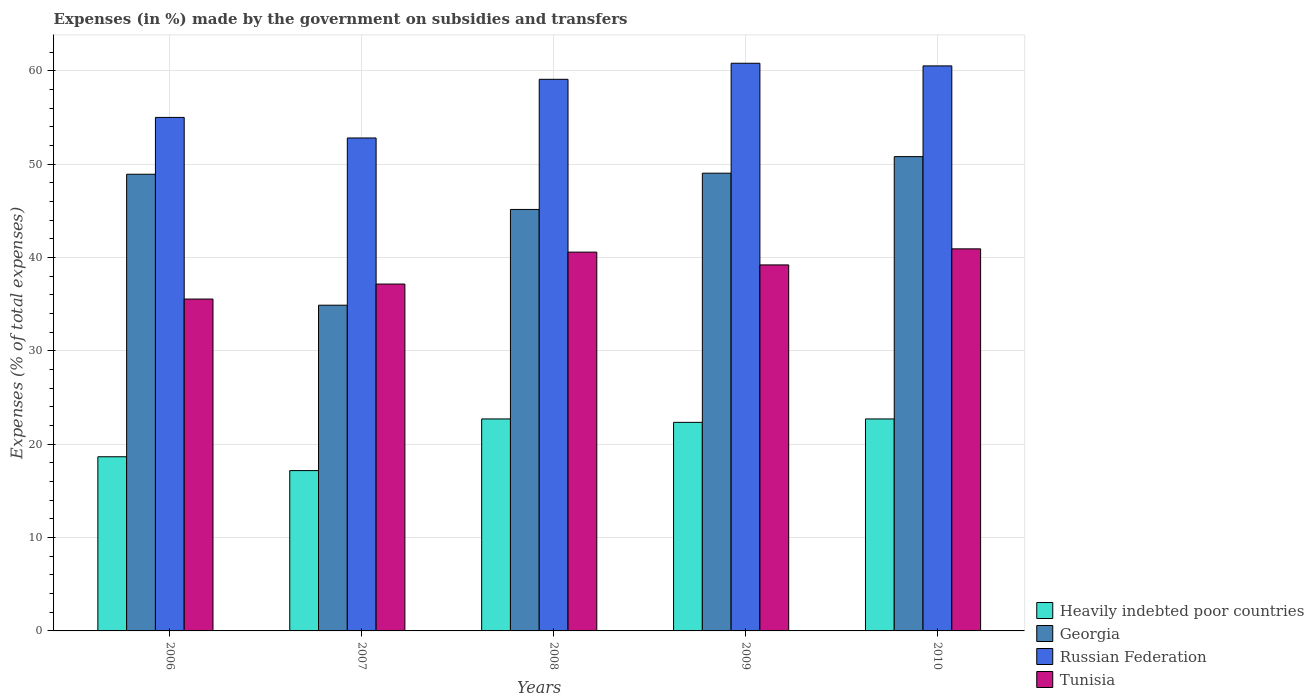How many different coloured bars are there?
Provide a short and direct response. 4. How many groups of bars are there?
Offer a very short reply. 5. Are the number of bars per tick equal to the number of legend labels?
Offer a terse response. Yes. How many bars are there on the 4th tick from the left?
Give a very brief answer. 4. In how many cases, is the number of bars for a given year not equal to the number of legend labels?
Keep it short and to the point. 0. What is the percentage of expenses made by the government on subsidies and transfers in Russian Federation in 2010?
Your answer should be very brief. 60.52. Across all years, what is the maximum percentage of expenses made by the government on subsidies and transfers in Tunisia?
Ensure brevity in your answer.  40.92. Across all years, what is the minimum percentage of expenses made by the government on subsidies and transfers in Georgia?
Offer a terse response. 34.89. In which year was the percentage of expenses made by the government on subsidies and transfers in Heavily indebted poor countries maximum?
Keep it short and to the point. 2010. What is the total percentage of expenses made by the government on subsidies and transfers in Georgia in the graph?
Give a very brief answer. 228.77. What is the difference between the percentage of expenses made by the government on subsidies and transfers in Russian Federation in 2009 and that in 2010?
Your answer should be very brief. 0.28. What is the difference between the percentage of expenses made by the government on subsidies and transfers in Russian Federation in 2007 and the percentage of expenses made by the government on subsidies and transfers in Heavily indebted poor countries in 2006?
Offer a terse response. 34.14. What is the average percentage of expenses made by the government on subsidies and transfers in Heavily indebted poor countries per year?
Provide a short and direct response. 20.71. In the year 2008, what is the difference between the percentage of expenses made by the government on subsidies and transfers in Russian Federation and percentage of expenses made by the government on subsidies and transfers in Georgia?
Your answer should be very brief. 13.94. In how many years, is the percentage of expenses made by the government on subsidies and transfers in Heavily indebted poor countries greater than 18 %?
Your answer should be compact. 4. What is the ratio of the percentage of expenses made by the government on subsidies and transfers in Heavily indebted poor countries in 2008 to that in 2010?
Keep it short and to the point. 1. What is the difference between the highest and the second highest percentage of expenses made by the government on subsidies and transfers in Tunisia?
Ensure brevity in your answer.  0.35. What is the difference between the highest and the lowest percentage of expenses made by the government on subsidies and transfers in Georgia?
Offer a very short reply. 15.91. In how many years, is the percentage of expenses made by the government on subsidies and transfers in Russian Federation greater than the average percentage of expenses made by the government on subsidies and transfers in Russian Federation taken over all years?
Offer a very short reply. 3. Is the sum of the percentage of expenses made by the government on subsidies and transfers in Russian Federation in 2008 and 2009 greater than the maximum percentage of expenses made by the government on subsidies and transfers in Georgia across all years?
Provide a succinct answer. Yes. Is it the case that in every year, the sum of the percentage of expenses made by the government on subsidies and transfers in Tunisia and percentage of expenses made by the government on subsidies and transfers in Heavily indebted poor countries is greater than the sum of percentage of expenses made by the government on subsidies and transfers in Russian Federation and percentage of expenses made by the government on subsidies and transfers in Georgia?
Keep it short and to the point. No. What does the 4th bar from the left in 2009 represents?
Your answer should be very brief. Tunisia. What does the 3rd bar from the right in 2007 represents?
Keep it short and to the point. Georgia. Are all the bars in the graph horizontal?
Offer a very short reply. No. What is the difference between two consecutive major ticks on the Y-axis?
Make the answer very short. 10. Does the graph contain any zero values?
Provide a succinct answer. No. How many legend labels are there?
Your answer should be very brief. 4. What is the title of the graph?
Give a very brief answer. Expenses (in %) made by the government on subsidies and transfers. Does "St. Vincent and the Grenadines" appear as one of the legend labels in the graph?
Ensure brevity in your answer.  No. What is the label or title of the X-axis?
Offer a terse response. Years. What is the label or title of the Y-axis?
Give a very brief answer. Expenses (% of total expenses). What is the Expenses (% of total expenses) of Heavily indebted poor countries in 2006?
Keep it short and to the point. 18.65. What is the Expenses (% of total expenses) of Georgia in 2006?
Offer a very short reply. 48.91. What is the Expenses (% of total expenses) of Russian Federation in 2006?
Ensure brevity in your answer.  55. What is the Expenses (% of total expenses) of Tunisia in 2006?
Keep it short and to the point. 35.55. What is the Expenses (% of total expenses) in Heavily indebted poor countries in 2007?
Make the answer very short. 17.17. What is the Expenses (% of total expenses) of Georgia in 2007?
Make the answer very short. 34.89. What is the Expenses (% of total expenses) of Russian Federation in 2007?
Keep it short and to the point. 52.8. What is the Expenses (% of total expenses) of Tunisia in 2007?
Your answer should be very brief. 37.15. What is the Expenses (% of total expenses) in Heavily indebted poor countries in 2008?
Offer a very short reply. 22.7. What is the Expenses (% of total expenses) in Georgia in 2008?
Your answer should be compact. 45.14. What is the Expenses (% of total expenses) of Russian Federation in 2008?
Provide a succinct answer. 59.08. What is the Expenses (% of total expenses) in Tunisia in 2008?
Ensure brevity in your answer.  40.57. What is the Expenses (% of total expenses) in Heavily indebted poor countries in 2009?
Provide a short and direct response. 22.34. What is the Expenses (% of total expenses) in Georgia in 2009?
Your answer should be very brief. 49.03. What is the Expenses (% of total expenses) of Russian Federation in 2009?
Keep it short and to the point. 60.8. What is the Expenses (% of total expenses) of Tunisia in 2009?
Provide a short and direct response. 39.2. What is the Expenses (% of total expenses) of Heavily indebted poor countries in 2010?
Ensure brevity in your answer.  22.7. What is the Expenses (% of total expenses) of Georgia in 2010?
Your answer should be compact. 50.8. What is the Expenses (% of total expenses) of Russian Federation in 2010?
Make the answer very short. 60.52. What is the Expenses (% of total expenses) in Tunisia in 2010?
Your answer should be compact. 40.92. Across all years, what is the maximum Expenses (% of total expenses) in Heavily indebted poor countries?
Your answer should be very brief. 22.7. Across all years, what is the maximum Expenses (% of total expenses) in Georgia?
Give a very brief answer. 50.8. Across all years, what is the maximum Expenses (% of total expenses) of Russian Federation?
Give a very brief answer. 60.8. Across all years, what is the maximum Expenses (% of total expenses) of Tunisia?
Make the answer very short. 40.92. Across all years, what is the minimum Expenses (% of total expenses) in Heavily indebted poor countries?
Your answer should be very brief. 17.17. Across all years, what is the minimum Expenses (% of total expenses) of Georgia?
Ensure brevity in your answer.  34.89. Across all years, what is the minimum Expenses (% of total expenses) of Russian Federation?
Provide a short and direct response. 52.8. Across all years, what is the minimum Expenses (% of total expenses) in Tunisia?
Offer a very short reply. 35.55. What is the total Expenses (% of total expenses) of Heavily indebted poor countries in the graph?
Offer a very short reply. 103.57. What is the total Expenses (% of total expenses) of Georgia in the graph?
Your answer should be very brief. 228.77. What is the total Expenses (% of total expenses) of Russian Federation in the graph?
Your response must be concise. 288.19. What is the total Expenses (% of total expenses) of Tunisia in the graph?
Your answer should be compact. 193.39. What is the difference between the Expenses (% of total expenses) in Heavily indebted poor countries in 2006 and that in 2007?
Provide a short and direct response. 1.48. What is the difference between the Expenses (% of total expenses) of Georgia in 2006 and that in 2007?
Keep it short and to the point. 14.03. What is the difference between the Expenses (% of total expenses) in Russian Federation in 2006 and that in 2007?
Your answer should be very brief. 2.2. What is the difference between the Expenses (% of total expenses) of Tunisia in 2006 and that in 2007?
Offer a terse response. -1.61. What is the difference between the Expenses (% of total expenses) of Heavily indebted poor countries in 2006 and that in 2008?
Offer a very short reply. -4.05. What is the difference between the Expenses (% of total expenses) of Georgia in 2006 and that in 2008?
Provide a short and direct response. 3.77. What is the difference between the Expenses (% of total expenses) of Russian Federation in 2006 and that in 2008?
Offer a terse response. -4.08. What is the difference between the Expenses (% of total expenses) in Tunisia in 2006 and that in 2008?
Keep it short and to the point. -5.03. What is the difference between the Expenses (% of total expenses) of Heavily indebted poor countries in 2006 and that in 2009?
Offer a very short reply. -3.69. What is the difference between the Expenses (% of total expenses) of Georgia in 2006 and that in 2009?
Ensure brevity in your answer.  -0.11. What is the difference between the Expenses (% of total expenses) in Russian Federation in 2006 and that in 2009?
Provide a succinct answer. -5.8. What is the difference between the Expenses (% of total expenses) in Tunisia in 2006 and that in 2009?
Your answer should be very brief. -3.66. What is the difference between the Expenses (% of total expenses) in Heavily indebted poor countries in 2006 and that in 2010?
Your answer should be compact. -4.05. What is the difference between the Expenses (% of total expenses) of Georgia in 2006 and that in 2010?
Provide a short and direct response. -1.89. What is the difference between the Expenses (% of total expenses) of Russian Federation in 2006 and that in 2010?
Your answer should be compact. -5.52. What is the difference between the Expenses (% of total expenses) of Tunisia in 2006 and that in 2010?
Give a very brief answer. -5.38. What is the difference between the Expenses (% of total expenses) in Heavily indebted poor countries in 2007 and that in 2008?
Give a very brief answer. -5.53. What is the difference between the Expenses (% of total expenses) of Georgia in 2007 and that in 2008?
Your response must be concise. -10.26. What is the difference between the Expenses (% of total expenses) in Russian Federation in 2007 and that in 2008?
Provide a succinct answer. -6.28. What is the difference between the Expenses (% of total expenses) of Tunisia in 2007 and that in 2008?
Your response must be concise. -3.42. What is the difference between the Expenses (% of total expenses) of Heavily indebted poor countries in 2007 and that in 2009?
Your answer should be compact. -5.17. What is the difference between the Expenses (% of total expenses) of Georgia in 2007 and that in 2009?
Provide a succinct answer. -14.14. What is the difference between the Expenses (% of total expenses) of Russian Federation in 2007 and that in 2009?
Offer a terse response. -8. What is the difference between the Expenses (% of total expenses) in Tunisia in 2007 and that in 2009?
Your answer should be very brief. -2.05. What is the difference between the Expenses (% of total expenses) in Heavily indebted poor countries in 2007 and that in 2010?
Provide a succinct answer. -5.53. What is the difference between the Expenses (% of total expenses) of Georgia in 2007 and that in 2010?
Provide a short and direct response. -15.91. What is the difference between the Expenses (% of total expenses) in Russian Federation in 2007 and that in 2010?
Keep it short and to the point. -7.72. What is the difference between the Expenses (% of total expenses) of Tunisia in 2007 and that in 2010?
Your response must be concise. -3.77. What is the difference between the Expenses (% of total expenses) in Heavily indebted poor countries in 2008 and that in 2009?
Your answer should be compact. 0.36. What is the difference between the Expenses (% of total expenses) in Georgia in 2008 and that in 2009?
Offer a very short reply. -3.88. What is the difference between the Expenses (% of total expenses) of Russian Federation in 2008 and that in 2009?
Provide a short and direct response. -1.72. What is the difference between the Expenses (% of total expenses) in Tunisia in 2008 and that in 2009?
Your response must be concise. 1.37. What is the difference between the Expenses (% of total expenses) of Heavily indebted poor countries in 2008 and that in 2010?
Offer a very short reply. -0. What is the difference between the Expenses (% of total expenses) in Georgia in 2008 and that in 2010?
Make the answer very short. -5.66. What is the difference between the Expenses (% of total expenses) of Russian Federation in 2008 and that in 2010?
Offer a terse response. -1.44. What is the difference between the Expenses (% of total expenses) in Tunisia in 2008 and that in 2010?
Your response must be concise. -0.35. What is the difference between the Expenses (% of total expenses) of Heavily indebted poor countries in 2009 and that in 2010?
Provide a short and direct response. -0.37. What is the difference between the Expenses (% of total expenses) in Georgia in 2009 and that in 2010?
Your answer should be very brief. -1.78. What is the difference between the Expenses (% of total expenses) in Russian Federation in 2009 and that in 2010?
Make the answer very short. 0.28. What is the difference between the Expenses (% of total expenses) of Tunisia in 2009 and that in 2010?
Offer a terse response. -1.72. What is the difference between the Expenses (% of total expenses) in Heavily indebted poor countries in 2006 and the Expenses (% of total expenses) in Georgia in 2007?
Your answer should be very brief. -16.23. What is the difference between the Expenses (% of total expenses) in Heavily indebted poor countries in 2006 and the Expenses (% of total expenses) in Russian Federation in 2007?
Make the answer very short. -34.14. What is the difference between the Expenses (% of total expenses) of Heavily indebted poor countries in 2006 and the Expenses (% of total expenses) of Tunisia in 2007?
Your answer should be very brief. -18.5. What is the difference between the Expenses (% of total expenses) in Georgia in 2006 and the Expenses (% of total expenses) in Russian Federation in 2007?
Make the answer very short. -3.88. What is the difference between the Expenses (% of total expenses) of Georgia in 2006 and the Expenses (% of total expenses) of Tunisia in 2007?
Make the answer very short. 11.76. What is the difference between the Expenses (% of total expenses) in Russian Federation in 2006 and the Expenses (% of total expenses) in Tunisia in 2007?
Make the answer very short. 17.85. What is the difference between the Expenses (% of total expenses) of Heavily indebted poor countries in 2006 and the Expenses (% of total expenses) of Georgia in 2008?
Provide a succinct answer. -26.49. What is the difference between the Expenses (% of total expenses) of Heavily indebted poor countries in 2006 and the Expenses (% of total expenses) of Russian Federation in 2008?
Provide a succinct answer. -40.43. What is the difference between the Expenses (% of total expenses) of Heavily indebted poor countries in 2006 and the Expenses (% of total expenses) of Tunisia in 2008?
Your answer should be compact. -21.92. What is the difference between the Expenses (% of total expenses) of Georgia in 2006 and the Expenses (% of total expenses) of Russian Federation in 2008?
Keep it short and to the point. -10.17. What is the difference between the Expenses (% of total expenses) in Georgia in 2006 and the Expenses (% of total expenses) in Tunisia in 2008?
Give a very brief answer. 8.34. What is the difference between the Expenses (% of total expenses) of Russian Federation in 2006 and the Expenses (% of total expenses) of Tunisia in 2008?
Your answer should be compact. 14.43. What is the difference between the Expenses (% of total expenses) in Heavily indebted poor countries in 2006 and the Expenses (% of total expenses) in Georgia in 2009?
Make the answer very short. -30.37. What is the difference between the Expenses (% of total expenses) in Heavily indebted poor countries in 2006 and the Expenses (% of total expenses) in Russian Federation in 2009?
Keep it short and to the point. -42.15. What is the difference between the Expenses (% of total expenses) in Heavily indebted poor countries in 2006 and the Expenses (% of total expenses) in Tunisia in 2009?
Provide a succinct answer. -20.55. What is the difference between the Expenses (% of total expenses) in Georgia in 2006 and the Expenses (% of total expenses) in Russian Federation in 2009?
Your response must be concise. -11.89. What is the difference between the Expenses (% of total expenses) of Georgia in 2006 and the Expenses (% of total expenses) of Tunisia in 2009?
Make the answer very short. 9.71. What is the difference between the Expenses (% of total expenses) of Russian Federation in 2006 and the Expenses (% of total expenses) of Tunisia in 2009?
Make the answer very short. 15.8. What is the difference between the Expenses (% of total expenses) in Heavily indebted poor countries in 2006 and the Expenses (% of total expenses) in Georgia in 2010?
Give a very brief answer. -32.15. What is the difference between the Expenses (% of total expenses) in Heavily indebted poor countries in 2006 and the Expenses (% of total expenses) in Russian Federation in 2010?
Offer a very short reply. -41.86. What is the difference between the Expenses (% of total expenses) in Heavily indebted poor countries in 2006 and the Expenses (% of total expenses) in Tunisia in 2010?
Your response must be concise. -22.27. What is the difference between the Expenses (% of total expenses) in Georgia in 2006 and the Expenses (% of total expenses) in Russian Federation in 2010?
Your answer should be very brief. -11.6. What is the difference between the Expenses (% of total expenses) of Georgia in 2006 and the Expenses (% of total expenses) of Tunisia in 2010?
Your answer should be compact. 7.99. What is the difference between the Expenses (% of total expenses) of Russian Federation in 2006 and the Expenses (% of total expenses) of Tunisia in 2010?
Make the answer very short. 14.08. What is the difference between the Expenses (% of total expenses) of Heavily indebted poor countries in 2007 and the Expenses (% of total expenses) of Georgia in 2008?
Offer a very short reply. -27.97. What is the difference between the Expenses (% of total expenses) in Heavily indebted poor countries in 2007 and the Expenses (% of total expenses) in Russian Federation in 2008?
Make the answer very short. -41.91. What is the difference between the Expenses (% of total expenses) in Heavily indebted poor countries in 2007 and the Expenses (% of total expenses) in Tunisia in 2008?
Offer a very short reply. -23.4. What is the difference between the Expenses (% of total expenses) of Georgia in 2007 and the Expenses (% of total expenses) of Russian Federation in 2008?
Ensure brevity in your answer.  -24.19. What is the difference between the Expenses (% of total expenses) of Georgia in 2007 and the Expenses (% of total expenses) of Tunisia in 2008?
Give a very brief answer. -5.69. What is the difference between the Expenses (% of total expenses) in Russian Federation in 2007 and the Expenses (% of total expenses) in Tunisia in 2008?
Your answer should be very brief. 12.22. What is the difference between the Expenses (% of total expenses) in Heavily indebted poor countries in 2007 and the Expenses (% of total expenses) in Georgia in 2009?
Offer a terse response. -31.85. What is the difference between the Expenses (% of total expenses) in Heavily indebted poor countries in 2007 and the Expenses (% of total expenses) in Russian Federation in 2009?
Offer a very short reply. -43.63. What is the difference between the Expenses (% of total expenses) of Heavily indebted poor countries in 2007 and the Expenses (% of total expenses) of Tunisia in 2009?
Offer a very short reply. -22.03. What is the difference between the Expenses (% of total expenses) of Georgia in 2007 and the Expenses (% of total expenses) of Russian Federation in 2009?
Keep it short and to the point. -25.91. What is the difference between the Expenses (% of total expenses) in Georgia in 2007 and the Expenses (% of total expenses) in Tunisia in 2009?
Ensure brevity in your answer.  -4.31. What is the difference between the Expenses (% of total expenses) in Russian Federation in 2007 and the Expenses (% of total expenses) in Tunisia in 2009?
Your response must be concise. 13.6. What is the difference between the Expenses (% of total expenses) of Heavily indebted poor countries in 2007 and the Expenses (% of total expenses) of Georgia in 2010?
Offer a very short reply. -33.63. What is the difference between the Expenses (% of total expenses) of Heavily indebted poor countries in 2007 and the Expenses (% of total expenses) of Russian Federation in 2010?
Your response must be concise. -43.35. What is the difference between the Expenses (% of total expenses) of Heavily indebted poor countries in 2007 and the Expenses (% of total expenses) of Tunisia in 2010?
Provide a short and direct response. -23.75. What is the difference between the Expenses (% of total expenses) of Georgia in 2007 and the Expenses (% of total expenses) of Russian Federation in 2010?
Provide a succinct answer. -25.63. What is the difference between the Expenses (% of total expenses) of Georgia in 2007 and the Expenses (% of total expenses) of Tunisia in 2010?
Ensure brevity in your answer.  -6.03. What is the difference between the Expenses (% of total expenses) of Russian Federation in 2007 and the Expenses (% of total expenses) of Tunisia in 2010?
Provide a short and direct response. 11.88. What is the difference between the Expenses (% of total expenses) of Heavily indebted poor countries in 2008 and the Expenses (% of total expenses) of Georgia in 2009?
Your response must be concise. -26.32. What is the difference between the Expenses (% of total expenses) in Heavily indebted poor countries in 2008 and the Expenses (% of total expenses) in Russian Federation in 2009?
Your response must be concise. -38.1. What is the difference between the Expenses (% of total expenses) of Heavily indebted poor countries in 2008 and the Expenses (% of total expenses) of Tunisia in 2009?
Provide a short and direct response. -16.5. What is the difference between the Expenses (% of total expenses) of Georgia in 2008 and the Expenses (% of total expenses) of Russian Federation in 2009?
Offer a very short reply. -15.66. What is the difference between the Expenses (% of total expenses) in Georgia in 2008 and the Expenses (% of total expenses) in Tunisia in 2009?
Provide a short and direct response. 5.94. What is the difference between the Expenses (% of total expenses) in Russian Federation in 2008 and the Expenses (% of total expenses) in Tunisia in 2009?
Give a very brief answer. 19.88. What is the difference between the Expenses (% of total expenses) in Heavily indebted poor countries in 2008 and the Expenses (% of total expenses) in Georgia in 2010?
Offer a very short reply. -28.1. What is the difference between the Expenses (% of total expenses) of Heavily indebted poor countries in 2008 and the Expenses (% of total expenses) of Russian Federation in 2010?
Ensure brevity in your answer.  -37.81. What is the difference between the Expenses (% of total expenses) in Heavily indebted poor countries in 2008 and the Expenses (% of total expenses) in Tunisia in 2010?
Keep it short and to the point. -18.22. What is the difference between the Expenses (% of total expenses) of Georgia in 2008 and the Expenses (% of total expenses) of Russian Federation in 2010?
Give a very brief answer. -15.38. What is the difference between the Expenses (% of total expenses) in Georgia in 2008 and the Expenses (% of total expenses) in Tunisia in 2010?
Give a very brief answer. 4.22. What is the difference between the Expenses (% of total expenses) of Russian Federation in 2008 and the Expenses (% of total expenses) of Tunisia in 2010?
Keep it short and to the point. 18.16. What is the difference between the Expenses (% of total expenses) in Heavily indebted poor countries in 2009 and the Expenses (% of total expenses) in Georgia in 2010?
Offer a very short reply. -28.46. What is the difference between the Expenses (% of total expenses) of Heavily indebted poor countries in 2009 and the Expenses (% of total expenses) of Russian Federation in 2010?
Make the answer very short. -38.18. What is the difference between the Expenses (% of total expenses) of Heavily indebted poor countries in 2009 and the Expenses (% of total expenses) of Tunisia in 2010?
Offer a very short reply. -18.58. What is the difference between the Expenses (% of total expenses) of Georgia in 2009 and the Expenses (% of total expenses) of Russian Federation in 2010?
Your answer should be very brief. -11.49. What is the difference between the Expenses (% of total expenses) in Georgia in 2009 and the Expenses (% of total expenses) in Tunisia in 2010?
Keep it short and to the point. 8.1. What is the difference between the Expenses (% of total expenses) in Russian Federation in 2009 and the Expenses (% of total expenses) in Tunisia in 2010?
Your answer should be very brief. 19.88. What is the average Expenses (% of total expenses) in Heavily indebted poor countries per year?
Offer a terse response. 20.71. What is the average Expenses (% of total expenses) of Georgia per year?
Keep it short and to the point. 45.75. What is the average Expenses (% of total expenses) of Russian Federation per year?
Your response must be concise. 57.64. What is the average Expenses (% of total expenses) in Tunisia per year?
Ensure brevity in your answer.  38.68. In the year 2006, what is the difference between the Expenses (% of total expenses) in Heavily indebted poor countries and Expenses (% of total expenses) in Georgia?
Your answer should be compact. -30.26. In the year 2006, what is the difference between the Expenses (% of total expenses) of Heavily indebted poor countries and Expenses (% of total expenses) of Russian Federation?
Make the answer very short. -36.35. In the year 2006, what is the difference between the Expenses (% of total expenses) in Heavily indebted poor countries and Expenses (% of total expenses) in Tunisia?
Keep it short and to the point. -16.89. In the year 2006, what is the difference between the Expenses (% of total expenses) in Georgia and Expenses (% of total expenses) in Russian Federation?
Provide a succinct answer. -6.09. In the year 2006, what is the difference between the Expenses (% of total expenses) in Georgia and Expenses (% of total expenses) in Tunisia?
Your answer should be compact. 13.37. In the year 2006, what is the difference between the Expenses (% of total expenses) in Russian Federation and Expenses (% of total expenses) in Tunisia?
Ensure brevity in your answer.  19.45. In the year 2007, what is the difference between the Expenses (% of total expenses) of Heavily indebted poor countries and Expenses (% of total expenses) of Georgia?
Your answer should be compact. -17.72. In the year 2007, what is the difference between the Expenses (% of total expenses) of Heavily indebted poor countries and Expenses (% of total expenses) of Russian Federation?
Offer a very short reply. -35.63. In the year 2007, what is the difference between the Expenses (% of total expenses) of Heavily indebted poor countries and Expenses (% of total expenses) of Tunisia?
Provide a short and direct response. -19.98. In the year 2007, what is the difference between the Expenses (% of total expenses) in Georgia and Expenses (% of total expenses) in Russian Federation?
Give a very brief answer. -17.91. In the year 2007, what is the difference between the Expenses (% of total expenses) in Georgia and Expenses (% of total expenses) in Tunisia?
Make the answer very short. -2.27. In the year 2007, what is the difference between the Expenses (% of total expenses) in Russian Federation and Expenses (% of total expenses) in Tunisia?
Provide a succinct answer. 15.64. In the year 2008, what is the difference between the Expenses (% of total expenses) of Heavily indebted poor countries and Expenses (% of total expenses) of Georgia?
Provide a short and direct response. -22.44. In the year 2008, what is the difference between the Expenses (% of total expenses) of Heavily indebted poor countries and Expenses (% of total expenses) of Russian Federation?
Provide a succinct answer. -36.38. In the year 2008, what is the difference between the Expenses (% of total expenses) of Heavily indebted poor countries and Expenses (% of total expenses) of Tunisia?
Give a very brief answer. -17.87. In the year 2008, what is the difference between the Expenses (% of total expenses) of Georgia and Expenses (% of total expenses) of Russian Federation?
Ensure brevity in your answer.  -13.94. In the year 2008, what is the difference between the Expenses (% of total expenses) in Georgia and Expenses (% of total expenses) in Tunisia?
Provide a succinct answer. 4.57. In the year 2008, what is the difference between the Expenses (% of total expenses) in Russian Federation and Expenses (% of total expenses) in Tunisia?
Your response must be concise. 18.51. In the year 2009, what is the difference between the Expenses (% of total expenses) in Heavily indebted poor countries and Expenses (% of total expenses) in Georgia?
Your response must be concise. -26.69. In the year 2009, what is the difference between the Expenses (% of total expenses) of Heavily indebted poor countries and Expenses (% of total expenses) of Russian Federation?
Ensure brevity in your answer.  -38.46. In the year 2009, what is the difference between the Expenses (% of total expenses) in Heavily indebted poor countries and Expenses (% of total expenses) in Tunisia?
Ensure brevity in your answer.  -16.86. In the year 2009, what is the difference between the Expenses (% of total expenses) in Georgia and Expenses (% of total expenses) in Russian Federation?
Give a very brief answer. -11.77. In the year 2009, what is the difference between the Expenses (% of total expenses) of Georgia and Expenses (% of total expenses) of Tunisia?
Provide a short and direct response. 9.82. In the year 2009, what is the difference between the Expenses (% of total expenses) of Russian Federation and Expenses (% of total expenses) of Tunisia?
Keep it short and to the point. 21.6. In the year 2010, what is the difference between the Expenses (% of total expenses) in Heavily indebted poor countries and Expenses (% of total expenses) in Georgia?
Provide a succinct answer. -28.1. In the year 2010, what is the difference between the Expenses (% of total expenses) in Heavily indebted poor countries and Expenses (% of total expenses) in Russian Federation?
Offer a very short reply. -37.81. In the year 2010, what is the difference between the Expenses (% of total expenses) of Heavily indebted poor countries and Expenses (% of total expenses) of Tunisia?
Offer a very short reply. -18.22. In the year 2010, what is the difference between the Expenses (% of total expenses) in Georgia and Expenses (% of total expenses) in Russian Federation?
Provide a short and direct response. -9.72. In the year 2010, what is the difference between the Expenses (% of total expenses) of Georgia and Expenses (% of total expenses) of Tunisia?
Offer a terse response. 9.88. In the year 2010, what is the difference between the Expenses (% of total expenses) in Russian Federation and Expenses (% of total expenses) in Tunisia?
Your answer should be compact. 19.6. What is the ratio of the Expenses (% of total expenses) in Heavily indebted poor countries in 2006 to that in 2007?
Your answer should be compact. 1.09. What is the ratio of the Expenses (% of total expenses) of Georgia in 2006 to that in 2007?
Provide a short and direct response. 1.4. What is the ratio of the Expenses (% of total expenses) of Russian Federation in 2006 to that in 2007?
Provide a short and direct response. 1.04. What is the ratio of the Expenses (% of total expenses) in Tunisia in 2006 to that in 2007?
Make the answer very short. 0.96. What is the ratio of the Expenses (% of total expenses) in Heavily indebted poor countries in 2006 to that in 2008?
Ensure brevity in your answer.  0.82. What is the ratio of the Expenses (% of total expenses) in Georgia in 2006 to that in 2008?
Provide a succinct answer. 1.08. What is the ratio of the Expenses (% of total expenses) in Russian Federation in 2006 to that in 2008?
Your response must be concise. 0.93. What is the ratio of the Expenses (% of total expenses) in Tunisia in 2006 to that in 2008?
Keep it short and to the point. 0.88. What is the ratio of the Expenses (% of total expenses) in Heavily indebted poor countries in 2006 to that in 2009?
Ensure brevity in your answer.  0.83. What is the ratio of the Expenses (% of total expenses) of Georgia in 2006 to that in 2009?
Ensure brevity in your answer.  1. What is the ratio of the Expenses (% of total expenses) of Russian Federation in 2006 to that in 2009?
Give a very brief answer. 0.9. What is the ratio of the Expenses (% of total expenses) of Tunisia in 2006 to that in 2009?
Your response must be concise. 0.91. What is the ratio of the Expenses (% of total expenses) of Heavily indebted poor countries in 2006 to that in 2010?
Your answer should be very brief. 0.82. What is the ratio of the Expenses (% of total expenses) in Georgia in 2006 to that in 2010?
Provide a succinct answer. 0.96. What is the ratio of the Expenses (% of total expenses) in Russian Federation in 2006 to that in 2010?
Ensure brevity in your answer.  0.91. What is the ratio of the Expenses (% of total expenses) of Tunisia in 2006 to that in 2010?
Your answer should be compact. 0.87. What is the ratio of the Expenses (% of total expenses) of Heavily indebted poor countries in 2007 to that in 2008?
Offer a terse response. 0.76. What is the ratio of the Expenses (% of total expenses) in Georgia in 2007 to that in 2008?
Offer a terse response. 0.77. What is the ratio of the Expenses (% of total expenses) of Russian Federation in 2007 to that in 2008?
Ensure brevity in your answer.  0.89. What is the ratio of the Expenses (% of total expenses) in Tunisia in 2007 to that in 2008?
Your answer should be compact. 0.92. What is the ratio of the Expenses (% of total expenses) in Heavily indebted poor countries in 2007 to that in 2009?
Offer a very short reply. 0.77. What is the ratio of the Expenses (% of total expenses) of Georgia in 2007 to that in 2009?
Your answer should be compact. 0.71. What is the ratio of the Expenses (% of total expenses) in Russian Federation in 2007 to that in 2009?
Offer a very short reply. 0.87. What is the ratio of the Expenses (% of total expenses) in Tunisia in 2007 to that in 2009?
Your answer should be very brief. 0.95. What is the ratio of the Expenses (% of total expenses) in Heavily indebted poor countries in 2007 to that in 2010?
Offer a very short reply. 0.76. What is the ratio of the Expenses (% of total expenses) of Georgia in 2007 to that in 2010?
Make the answer very short. 0.69. What is the ratio of the Expenses (% of total expenses) in Russian Federation in 2007 to that in 2010?
Provide a succinct answer. 0.87. What is the ratio of the Expenses (% of total expenses) in Tunisia in 2007 to that in 2010?
Make the answer very short. 0.91. What is the ratio of the Expenses (% of total expenses) in Heavily indebted poor countries in 2008 to that in 2009?
Your answer should be very brief. 1.02. What is the ratio of the Expenses (% of total expenses) of Georgia in 2008 to that in 2009?
Make the answer very short. 0.92. What is the ratio of the Expenses (% of total expenses) in Russian Federation in 2008 to that in 2009?
Your response must be concise. 0.97. What is the ratio of the Expenses (% of total expenses) in Tunisia in 2008 to that in 2009?
Keep it short and to the point. 1.03. What is the ratio of the Expenses (% of total expenses) in Georgia in 2008 to that in 2010?
Your answer should be very brief. 0.89. What is the ratio of the Expenses (% of total expenses) in Russian Federation in 2008 to that in 2010?
Ensure brevity in your answer.  0.98. What is the ratio of the Expenses (% of total expenses) of Heavily indebted poor countries in 2009 to that in 2010?
Give a very brief answer. 0.98. What is the ratio of the Expenses (% of total expenses) of Georgia in 2009 to that in 2010?
Your response must be concise. 0.97. What is the ratio of the Expenses (% of total expenses) of Tunisia in 2009 to that in 2010?
Your response must be concise. 0.96. What is the difference between the highest and the second highest Expenses (% of total expenses) in Heavily indebted poor countries?
Give a very brief answer. 0. What is the difference between the highest and the second highest Expenses (% of total expenses) of Georgia?
Your answer should be compact. 1.78. What is the difference between the highest and the second highest Expenses (% of total expenses) in Russian Federation?
Keep it short and to the point. 0.28. What is the difference between the highest and the second highest Expenses (% of total expenses) in Tunisia?
Offer a very short reply. 0.35. What is the difference between the highest and the lowest Expenses (% of total expenses) of Heavily indebted poor countries?
Your answer should be very brief. 5.53. What is the difference between the highest and the lowest Expenses (% of total expenses) in Georgia?
Give a very brief answer. 15.91. What is the difference between the highest and the lowest Expenses (% of total expenses) of Russian Federation?
Make the answer very short. 8. What is the difference between the highest and the lowest Expenses (% of total expenses) in Tunisia?
Offer a very short reply. 5.38. 